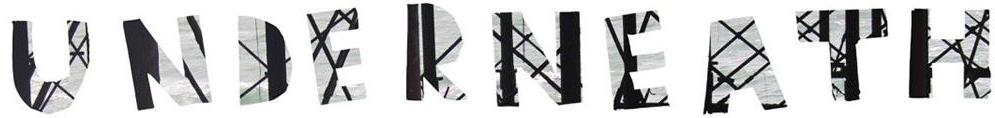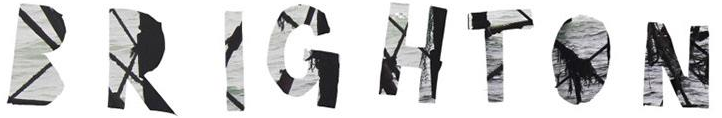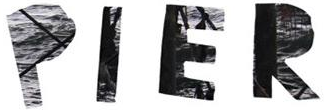What words are shown in these images in order, separated by a semicolon? UNDERNEATH; BRIGHTON; PIER 